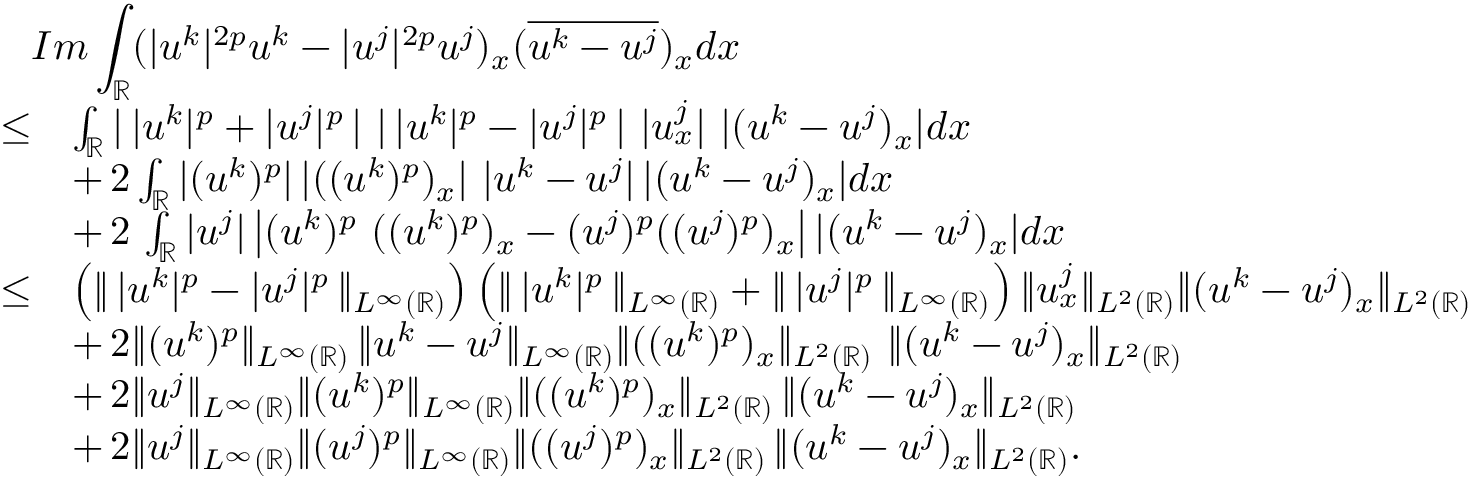<formula> <loc_0><loc_0><loc_500><loc_500>\begin{array} { r l } { { I m \int _ { \mathbb { R } } ( | u ^ { k } | ^ { 2 p } u ^ { k } - | u ^ { j } | ^ { 2 p } u ^ { j } ) _ { x } ( \overline { { u ^ { k } - u ^ { j } } } ) _ { x } d x } } \\ { \leq } & { \int _ { \mathbb { R } } | \, | u ^ { k } | ^ { p } + | u ^ { j } | ^ { p } \, | \ | \, | u ^ { k } | ^ { p } - | u ^ { j } | ^ { p } \, | \ | u _ { x } ^ { j } | \ | ( u ^ { k } - u ^ { j } ) _ { x } | d x } \\ & { + \, 2 \int _ { \mathbb { R } } | ( u ^ { k } ) ^ { p } | \, | ( ( u ^ { k } ) ^ { p } ) _ { x } | \ | u ^ { k } - u ^ { j } | \, | ( u ^ { k } - u ^ { j } ) _ { x } | d x } \\ & { + \, 2 \, \int _ { \mathbb { R } } | u ^ { j } | \left | ( u ^ { k } ) ^ { p } \ ( ( u ^ { k } ) ^ { p } ) _ { x } - ( u ^ { j } ) ^ { p } ( ( u ^ { j } ) ^ { p } ) _ { x } \right | | ( u ^ { k } - u ^ { j } ) _ { x } | d x } \\ { \leq } & { \left ( \| \, | u ^ { k } | ^ { p } - | u ^ { j } | ^ { p } \, \| _ { L ^ { \infty } ( \mathbb { R } ) } \right ) \left ( \| \, | u ^ { k } | ^ { p } \, \| _ { L ^ { \infty } ( \mathbb { R } ) } + \| \, | u ^ { j } | ^ { p } \, \| _ { L ^ { \infty } ( \mathbb { R } ) } \right ) \| u _ { x } ^ { j } \| _ { L ^ { 2 } ( \mathbb { R } ) } \| ( u ^ { k } - u ^ { j } ) _ { x } \| _ { L ^ { 2 } ( \mathbb { R } ) } } \\ & { + \, 2 \| ( u ^ { k } ) ^ { p } \| _ { L ^ { \infty } ( \mathbb { R } ) } \, \| u ^ { k } - u ^ { j } \| _ { L ^ { \infty } ( \mathbb { R } ) } \| ( ( u ^ { k } ) ^ { p } ) _ { x } \| _ { L ^ { 2 } ( \mathbb { R } ) } \ \| ( u ^ { k } - u ^ { j } ) _ { x } \| _ { L ^ { 2 } ( \mathbb { R } ) } } \\ & { + \, 2 \| u ^ { j } \| _ { L ^ { \infty } ( \mathbb { R } ) } \| ( u ^ { k } ) ^ { p } \| _ { L ^ { \infty } ( \mathbb { R } ) } \| ( ( u ^ { k } ) ^ { p } ) _ { x } \| _ { L ^ { 2 } ( \mathbb { R } ) } \, \| ( u ^ { k } - u ^ { j } ) _ { x } \| _ { L ^ { 2 } ( \mathbb { R } ) } } \\ & { + \, 2 \| u ^ { j } \| _ { L ^ { \infty } ( \mathbb { R } ) } \| ( u ^ { j } ) ^ { p } \| _ { L ^ { \infty } ( \mathbb { R } ) } \| ( ( u ^ { j } ) ^ { p } ) _ { x } \| _ { L ^ { 2 } ( \mathbb { R } ) } \, \| ( u ^ { k } - u ^ { j } ) _ { x } \| _ { L ^ { 2 } ( \mathbb { R } ) } . } \end{array}</formula> 